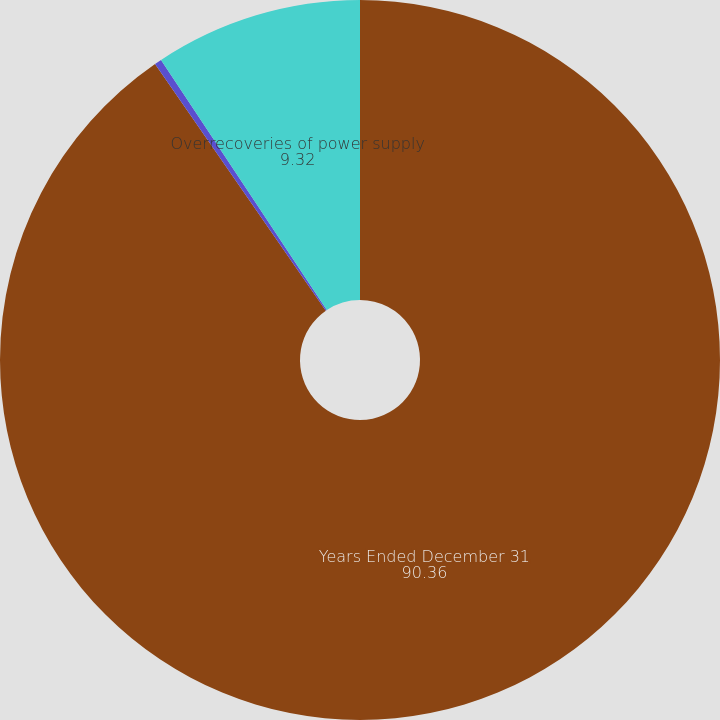Convert chart. <chart><loc_0><loc_0><loc_500><loc_500><pie_chart><fcel>Years Ended December 31<fcel>Underrecoveries of power<fcel>Overrecoveries of power supply<nl><fcel>90.36%<fcel>0.32%<fcel>9.32%<nl></chart> 